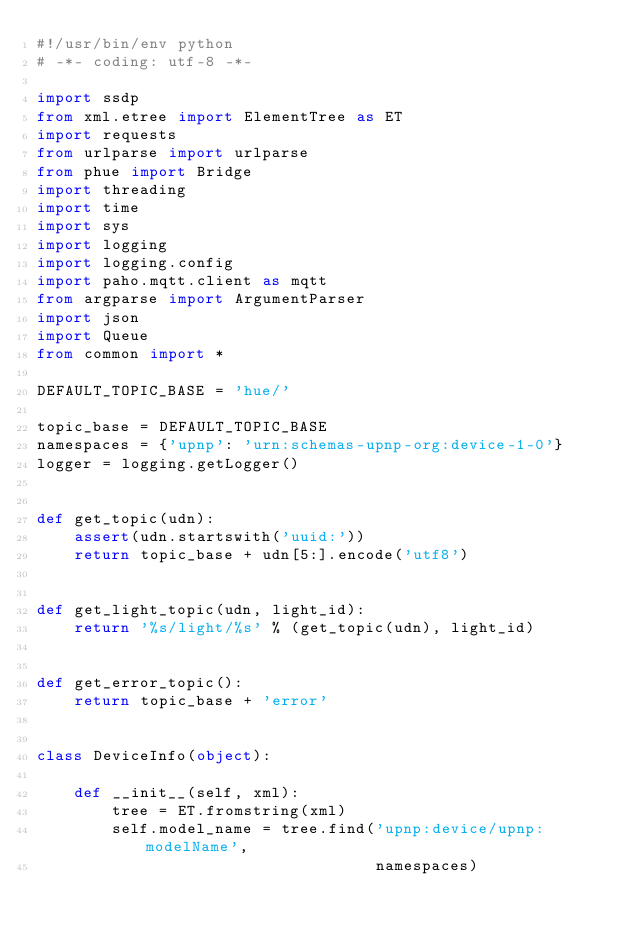<code> <loc_0><loc_0><loc_500><loc_500><_Python_>#!/usr/bin/env python
# -*- coding: utf-8 -*-

import ssdp
from xml.etree import ElementTree as ET
import requests
from urlparse import urlparse
from phue import Bridge
import threading
import time
import sys
import logging
import logging.config
import paho.mqtt.client as mqtt
from argparse import ArgumentParser
import json
import Queue
from common import *

DEFAULT_TOPIC_BASE = 'hue/'

topic_base = DEFAULT_TOPIC_BASE
namespaces = {'upnp': 'urn:schemas-upnp-org:device-1-0'}
logger = logging.getLogger()


def get_topic(udn):
    assert(udn.startswith('uuid:'))
    return topic_base + udn[5:].encode('utf8')


def get_light_topic(udn, light_id):
    return '%s/light/%s' % (get_topic(udn), light_id)


def get_error_topic():
    return topic_base + 'error'


class DeviceInfo(object):

    def __init__(self, xml):
        tree = ET.fromstring(xml)
        self.model_name = tree.find('upnp:device/upnp:modelName',
                                    namespaces)</code> 